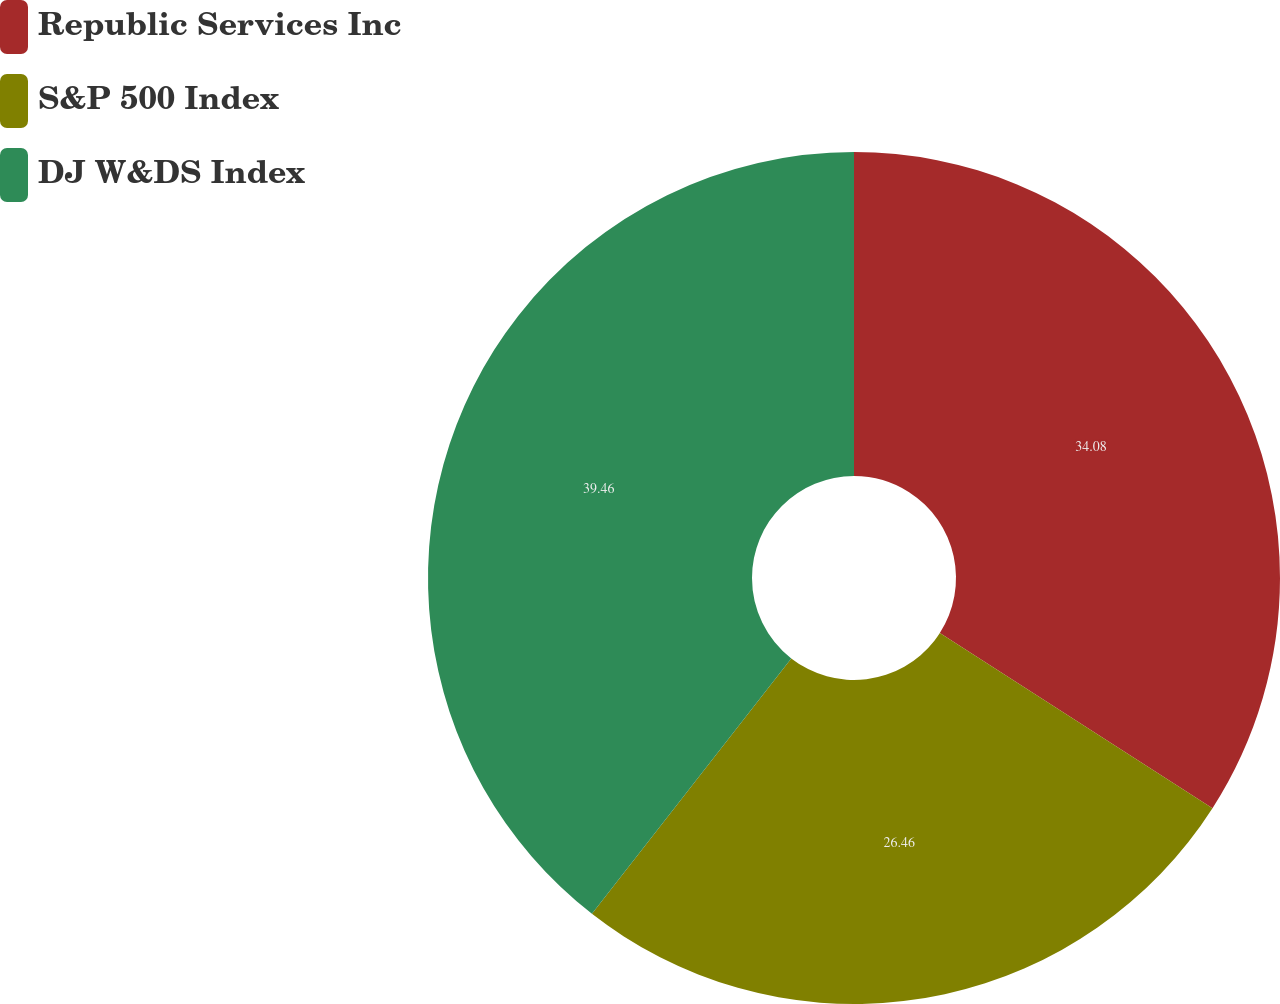Convert chart. <chart><loc_0><loc_0><loc_500><loc_500><pie_chart><fcel>Republic Services Inc<fcel>S&P 500 Index<fcel>DJ W&DS Index<nl><fcel>34.08%<fcel>26.46%<fcel>39.45%<nl></chart> 